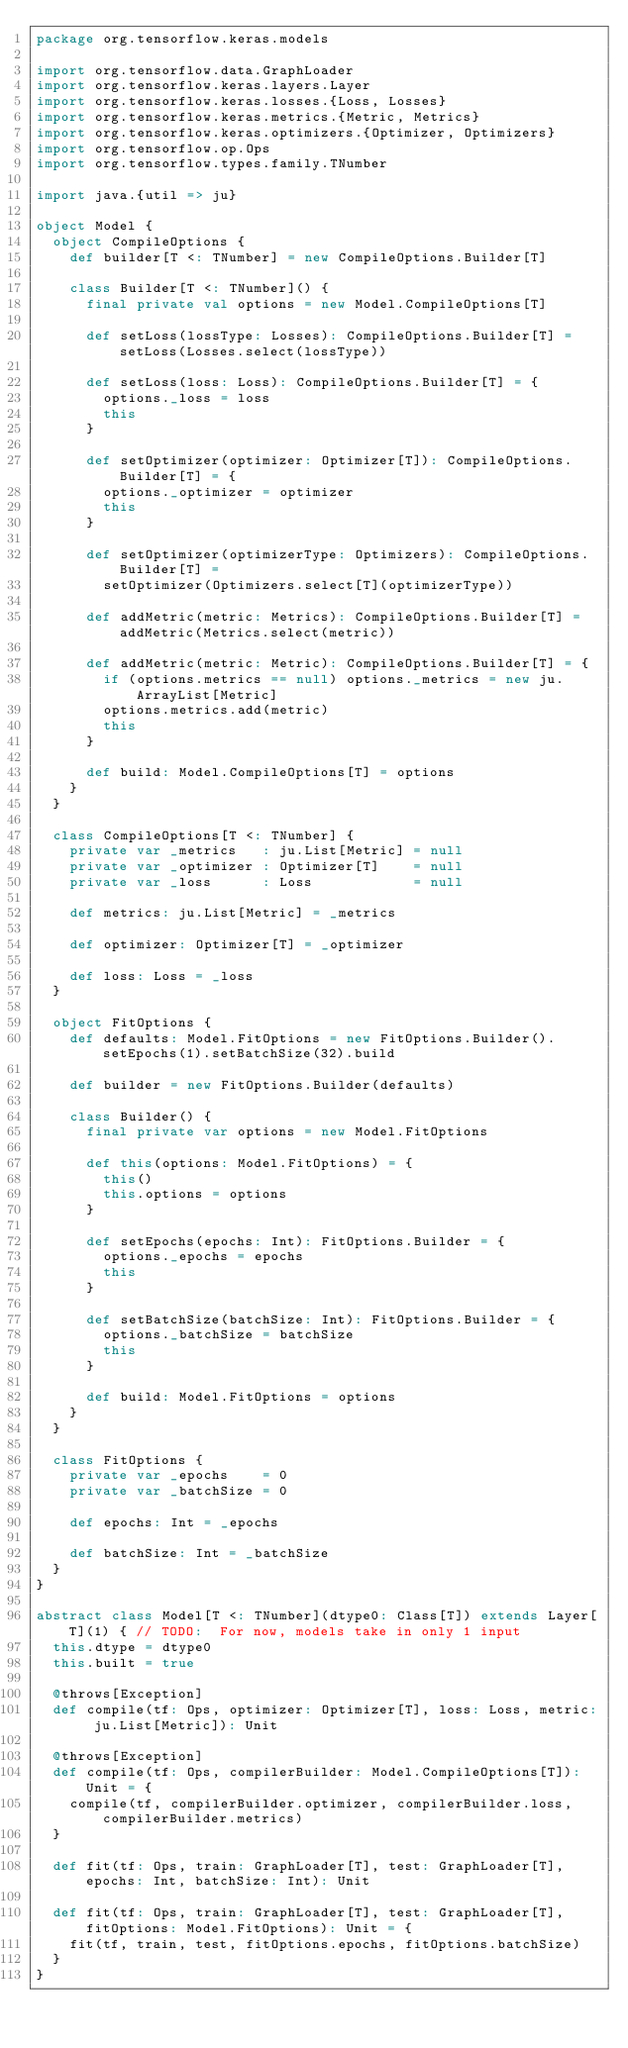Convert code to text. <code><loc_0><loc_0><loc_500><loc_500><_Scala_>package org.tensorflow.keras.models

import org.tensorflow.data.GraphLoader
import org.tensorflow.keras.layers.Layer
import org.tensorflow.keras.losses.{Loss, Losses}
import org.tensorflow.keras.metrics.{Metric, Metrics}
import org.tensorflow.keras.optimizers.{Optimizer, Optimizers}
import org.tensorflow.op.Ops
import org.tensorflow.types.family.TNumber

import java.{util => ju}

object Model {
  object CompileOptions {
    def builder[T <: TNumber] = new CompileOptions.Builder[T]

    class Builder[T <: TNumber]() {
      final private val options = new Model.CompileOptions[T]

      def setLoss(lossType: Losses): CompileOptions.Builder[T] = setLoss(Losses.select(lossType))

      def setLoss(loss: Loss): CompileOptions.Builder[T] = {
        options._loss = loss
        this
      }

      def setOptimizer(optimizer: Optimizer[T]): CompileOptions.Builder[T] = {
        options._optimizer = optimizer
        this
      }

      def setOptimizer(optimizerType: Optimizers): CompileOptions.Builder[T] =
        setOptimizer(Optimizers.select[T](optimizerType))

      def addMetric(metric: Metrics): CompileOptions.Builder[T] = addMetric(Metrics.select(metric))

      def addMetric(metric: Metric): CompileOptions.Builder[T] = {
        if (options.metrics == null) options._metrics = new ju.ArrayList[Metric]
        options.metrics.add(metric)
        this
      }

      def build: Model.CompileOptions[T] = options
    }
  }

  class CompileOptions[T <: TNumber] {
    private var _metrics   : ju.List[Metric] = null
    private var _optimizer : Optimizer[T]    = null
    private var _loss      : Loss            = null

    def metrics: ju.List[Metric] = _metrics

    def optimizer: Optimizer[T] = _optimizer

    def loss: Loss = _loss
  }

  object FitOptions {
    def defaults: Model.FitOptions = new FitOptions.Builder().setEpochs(1).setBatchSize(32).build

    def builder = new FitOptions.Builder(defaults)

    class Builder() {
      final private var options = new Model.FitOptions

      def this(options: Model.FitOptions) = {
        this()
        this.options = options
      }

      def setEpochs(epochs: Int): FitOptions.Builder = {
        options._epochs = epochs
        this
      }

      def setBatchSize(batchSize: Int): FitOptions.Builder = {
        options._batchSize = batchSize
        this
      }

      def build: Model.FitOptions = options
    }
  }

  class FitOptions {
    private var _epochs    = 0
    private var _batchSize = 0

    def epochs: Int = _epochs

    def batchSize: Int = _batchSize
  }
}

abstract class Model[T <: TNumber](dtype0: Class[T]) extends Layer[T](1) { // TODO:  For now, models take in only 1 input
  this.dtype = dtype0
  this.built = true

  @throws[Exception]
  def compile(tf: Ops, optimizer: Optimizer[T], loss: Loss, metric: ju.List[Metric]): Unit

  @throws[Exception]
  def compile(tf: Ops, compilerBuilder: Model.CompileOptions[T]): Unit = {
    compile(tf, compilerBuilder.optimizer, compilerBuilder.loss, compilerBuilder.metrics)
  }

  def fit(tf: Ops, train: GraphLoader[T], test: GraphLoader[T], epochs: Int, batchSize: Int): Unit

  def fit(tf: Ops, train: GraphLoader[T], test: GraphLoader[T], fitOptions: Model.FitOptions): Unit = {
    fit(tf, train, test, fitOptions.epochs, fitOptions.batchSize)
  }
}
</code> 